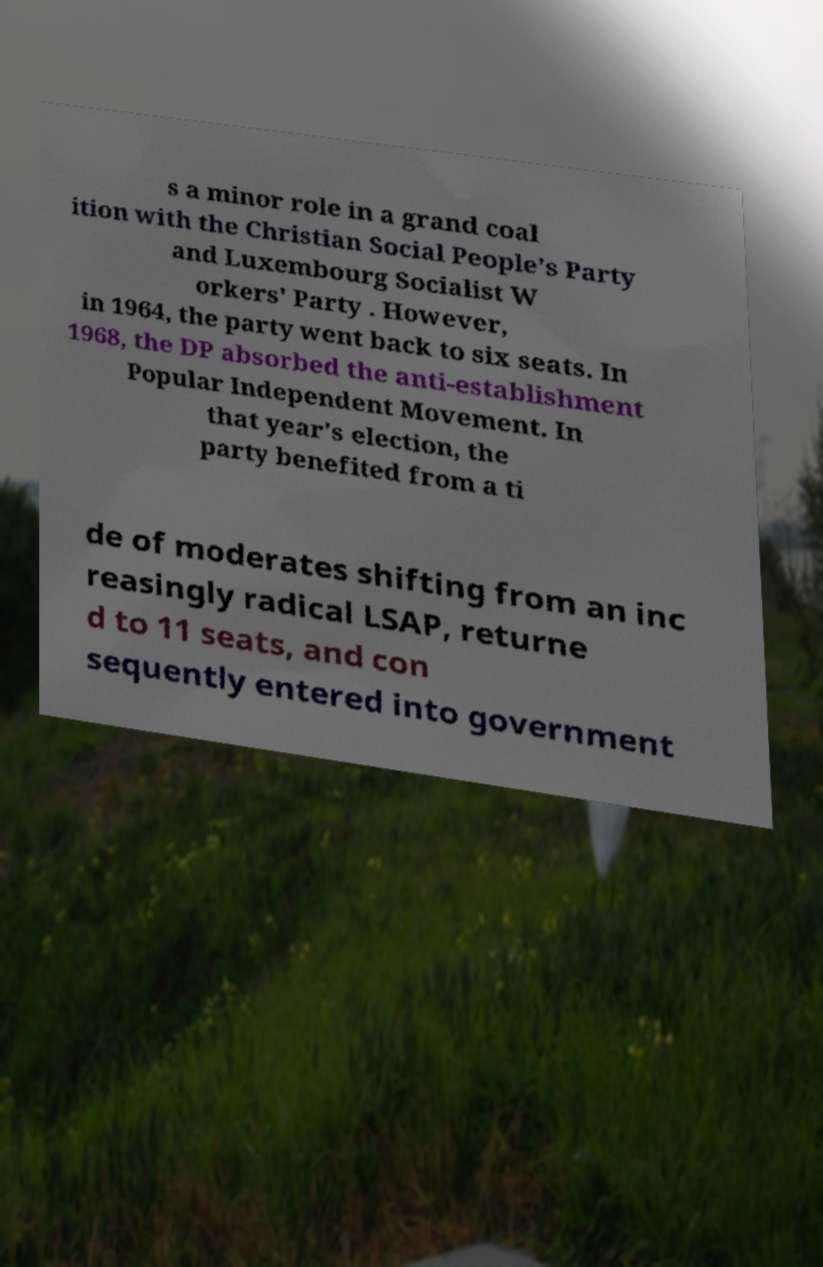Could you assist in decoding the text presented in this image and type it out clearly? s a minor role in a grand coal ition with the Christian Social People's Party and Luxembourg Socialist W orkers' Party . However, in 1964, the party went back to six seats. In 1968, the DP absorbed the anti-establishment Popular Independent Movement. In that year's election, the party benefited from a ti de of moderates shifting from an inc reasingly radical LSAP, returne d to 11 seats, and con sequently entered into government 